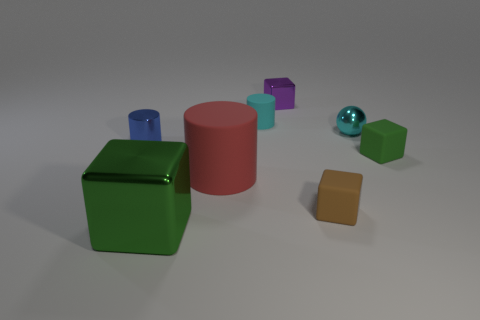Are there any other matte cylinders of the same color as the large cylinder?
Your answer should be compact. No. Is there a blue object?
Ensure brevity in your answer.  Yes. What is the color of the shiny cube that is right of the big cube?
Provide a short and direct response. Purple. There is a purple shiny thing; is its size the same as the metal ball on the right side of the red rubber thing?
Give a very brief answer. Yes. How big is the cube that is in front of the purple metal thing and behind the red rubber cylinder?
Offer a terse response. Small. Are there any large red cubes made of the same material as the small purple object?
Give a very brief answer. No. What is the shape of the large matte object?
Offer a very short reply. Cylinder. Do the cyan metallic ball and the purple metallic cube have the same size?
Provide a short and direct response. Yes. How many other things are there of the same shape as the green matte object?
Make the answer very short. 3. There is a tiny object left of the big cube; what shape is it?
Give a very brief answer. Cylinder. 